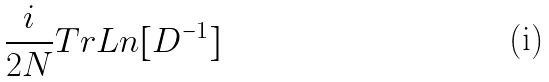<formula> <loc_0><loc_0><loc_500><loc_500>\frac { i } { 2 N } T r L n [ D ^ { - 1 } ]</formula> 